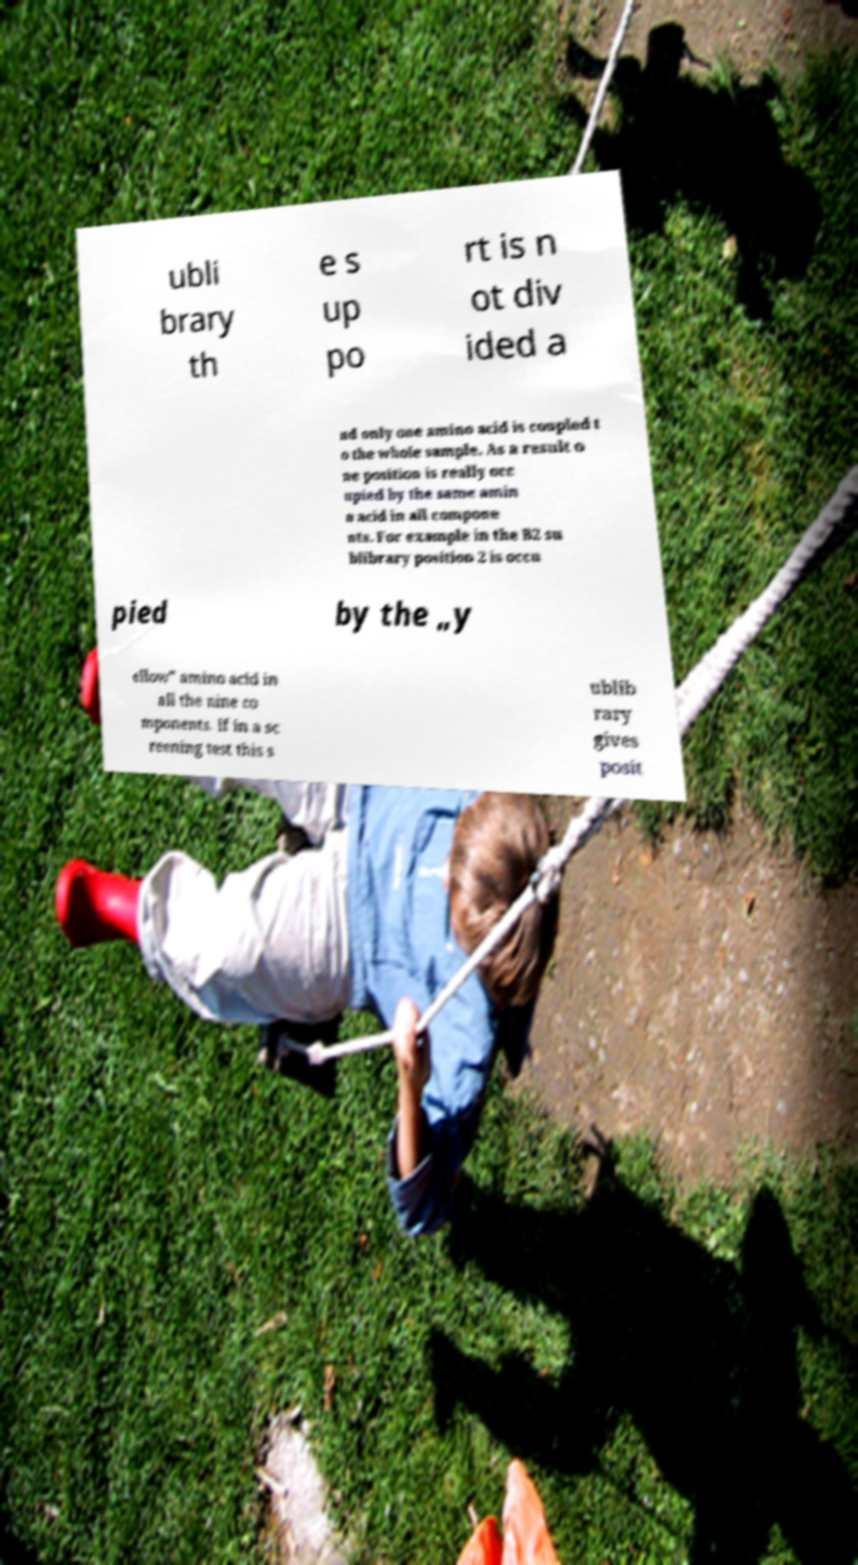I need the written content from this picture converted into text. Can you do that? ubli brary th e s up po rt is n ot div ided a nd only one amino acid is coupled t o the whole sample. As a result o ne position is really occ upied by the same amin o acid in all compone nts. For example in the B2 su blibrary position 2 is occu pied by the „y ellow” amino acid in all the nine co mponents. If in a sc reening test this s ublib rary gives posit 